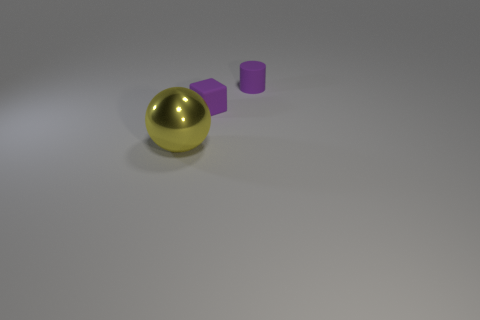Add 3 tiny purple matte cubes. How many objects exist? 6 Subtract 1 blocks. How many blocks are left? 0 Subtract all cylinders. How many objects are left? 2 Add 3 metallic objects. How many metallic objects are left? 4 Add 1 red metal spheres. How many red metal spheres exist? 1 Subtract 1 purple cylinders. How many objects are left? 2 Subtract all red blocks. Subtract all purple balls. How many blocks are left? 1 Subtract all tiny blue cubes. Subtract all large objects. How many objects are left? 2 